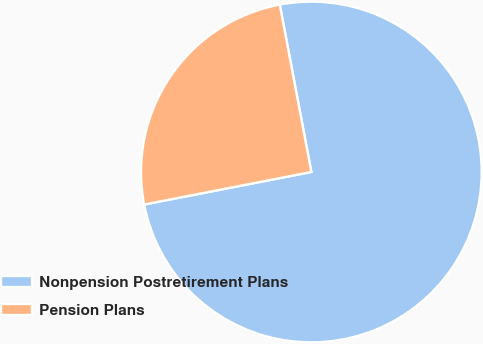Convert chart. <chart><loc_0><loc_0><loc_500><loc_500><pie_chart><fcel>Nonpension Postretirement Plans<fcel>Pension Plans<nl><fcel>74.91%<fcel>25.09%<nl></chart> 